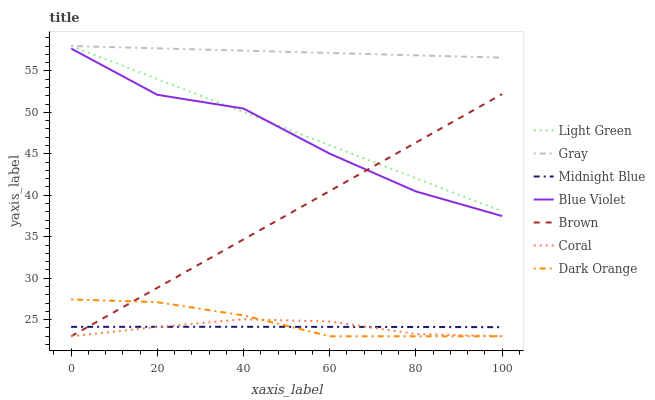Does Coral have the minimum area under the curve?
Answer yes or no. Yes. Does Gray have the maximum area under the curve?
Answer yes or no. Yes. Does Midnight Blue have the minimum area under the curve?
Answer yes or no. No. Does Midnight Blue have the maximum area under the curve?
Answer yes or no. No. Is Brown the smoothest?
Answer yes or no. Yes. Is Blue Violet the roughest?
Answer yes or no. Yes. Is Midnight Blue the smoothest?
Answer yes or no. No. Is Midnight Blue the roughest?
Answer yes or no. No. Does Brown have the lowest value?
Answer yes or no. Yes. Does Midnight Blue have the lowest value?
Answer yes or no. No. Does Light Green have the highest value?
Answer yes or no. Yes. Does Brown have the highest value?
Answer yes or no. No. Is Dark Orange less than Blue Violet?
Answer yes or no. Yes. Is Light Green greater than Midnight Blue?
Answer yes or no. Yes. Does Blue Violet intersect Light Green?
Answer yes or no. Yes. Is Blue Violet less than Light Green?
Answer yes or no. No. Is Blue Violet greater than Light Green?
Answer yes or no. No. Does Dark Orange intersect Blue Violet?
Answer yes or no. No. 